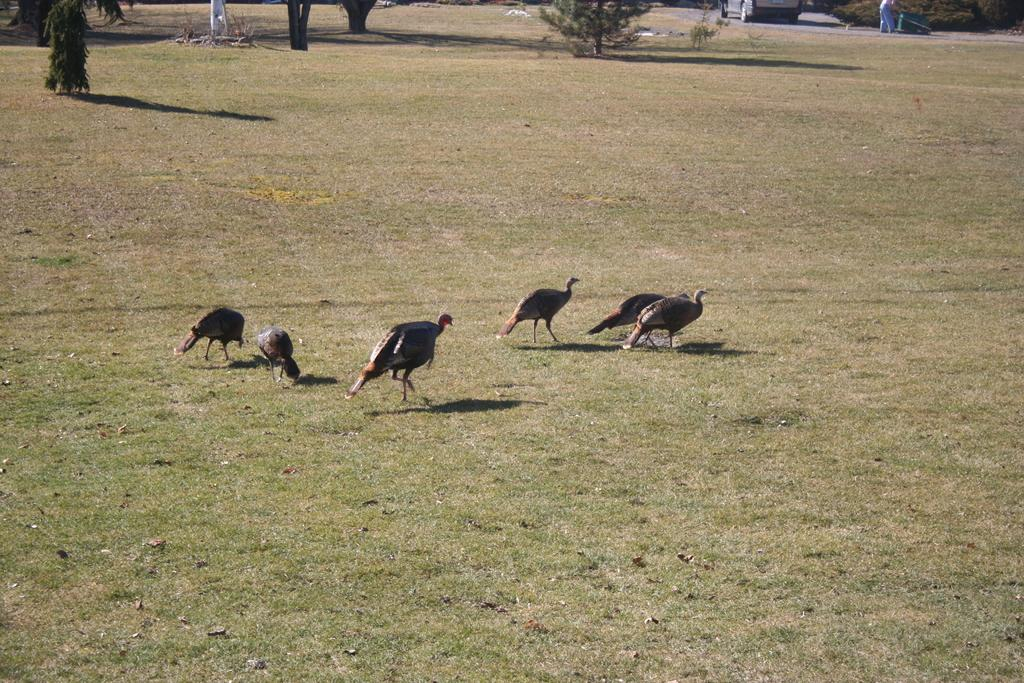What type of animals can be seen in the image? There are birds in the image. Where are the birds located? The birds are standing on a grass field. What else can be seen in the image besides the birds? Trees are present in the image. What type of silk is being used by the crowd in the image? There is no crowd or silk present in the image; it features birds standing on a grass field with trees in the background. 